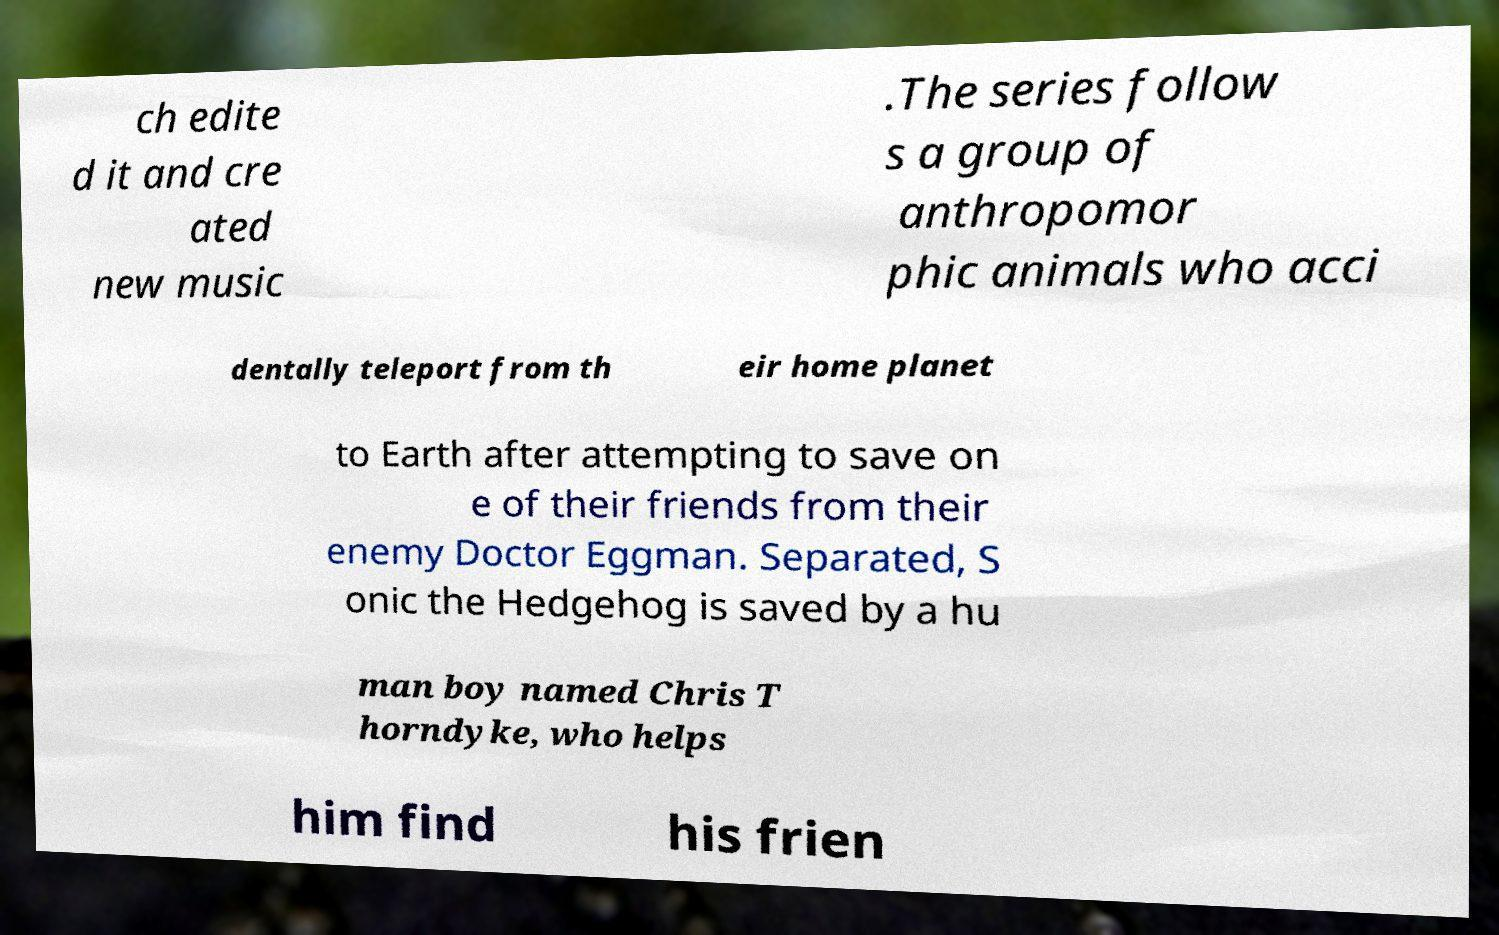Please identify and transcribe the text found in this image. ch edite d it and cre ated new music .The series follow s a group of anthropomor phic animals who acci dentally teleport from th eir home planet to Earth after attempting to save on e of their friends from their enemy Doctor Eggman. Separated, S onic the Hedgehog is saved by a hu man boy named Chris T horndyke, who helps him find his frien 